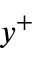Convert formula to latex. <formula><loc_0><loc_0><loc_500><loc_500>y ^ { + }</formula> 